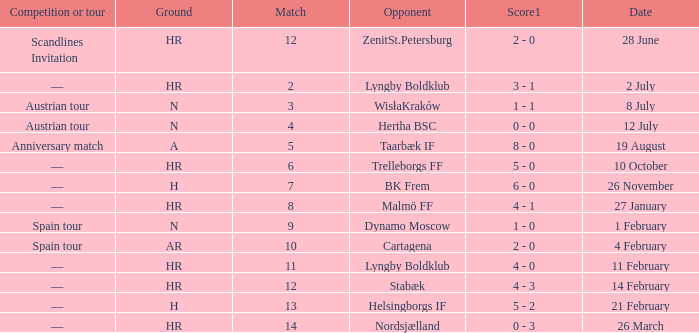In which competition or tour was nordsjælland the opponent with a hr Ground? —. 